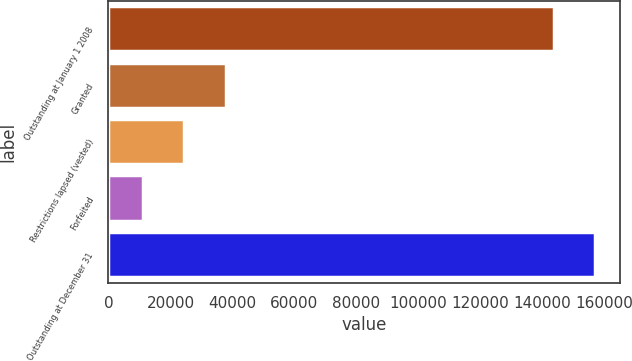Convert chart to OTSL. <chart><loc_0><loc_0><loc_500><loc_500><bar_chart><fcel>Outstanding at January 1 2008<fcel>Granted<fcel>Restrictions lapsed (vested)<fcel>Forfeited<fcel>Outstanding at December 31<nl><fcel>143609<fcel>37951.6<fcel>24485.8<fcel>11020<fcel>157075<nl></chart> 